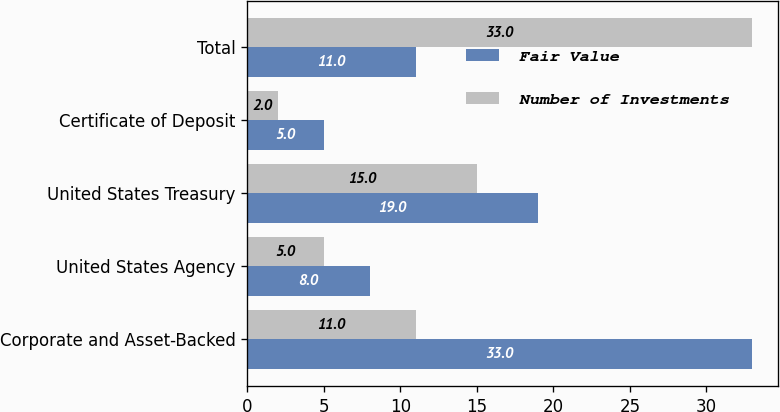<chart> <loc_0><loc_0><loc_500><loc_500><stacked_bar_chart><ecel><fcel>Corporate and Asset-Backed<fcel>United States Agency<fcel>United States Treasury<fcel>Certificate of Deposit<fcel>Total<nl><fcel>Fair Value<fcel>33<fcel>8<fcel>19<fcel>5<fcel>11<nl><fcel>Number of Investments<fcel>11<fcel>5<fcel>15<fcel>2<fcel>33<nl></chart> 